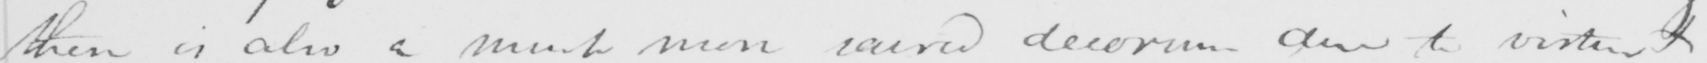Can you tell me what this handwritten text says? there is also a much more sacred decorum due to virtue  + 